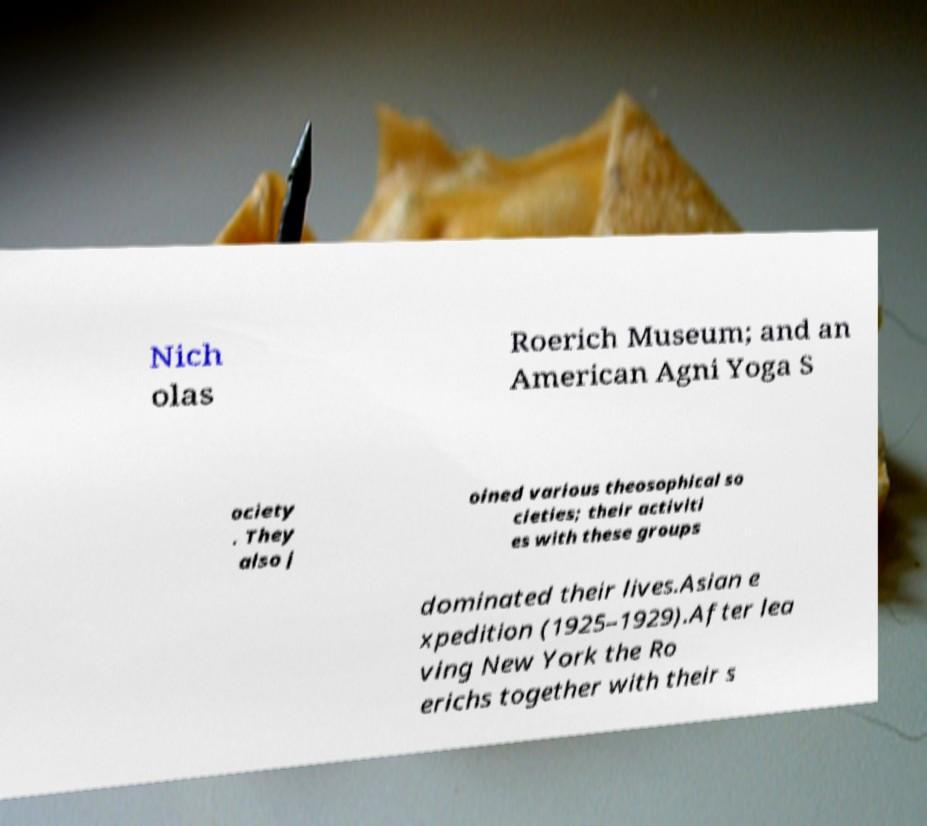Could you extract and type out the text from this image? Nich olas Roerich Museum; and an American Agni Yoga S ociety . They also j oined various theosophical so cieties; their activiti es with these groups dominated their lives.Asian e xpedition (1925–1929).After lea ving New York the Ro erichs together with their s 